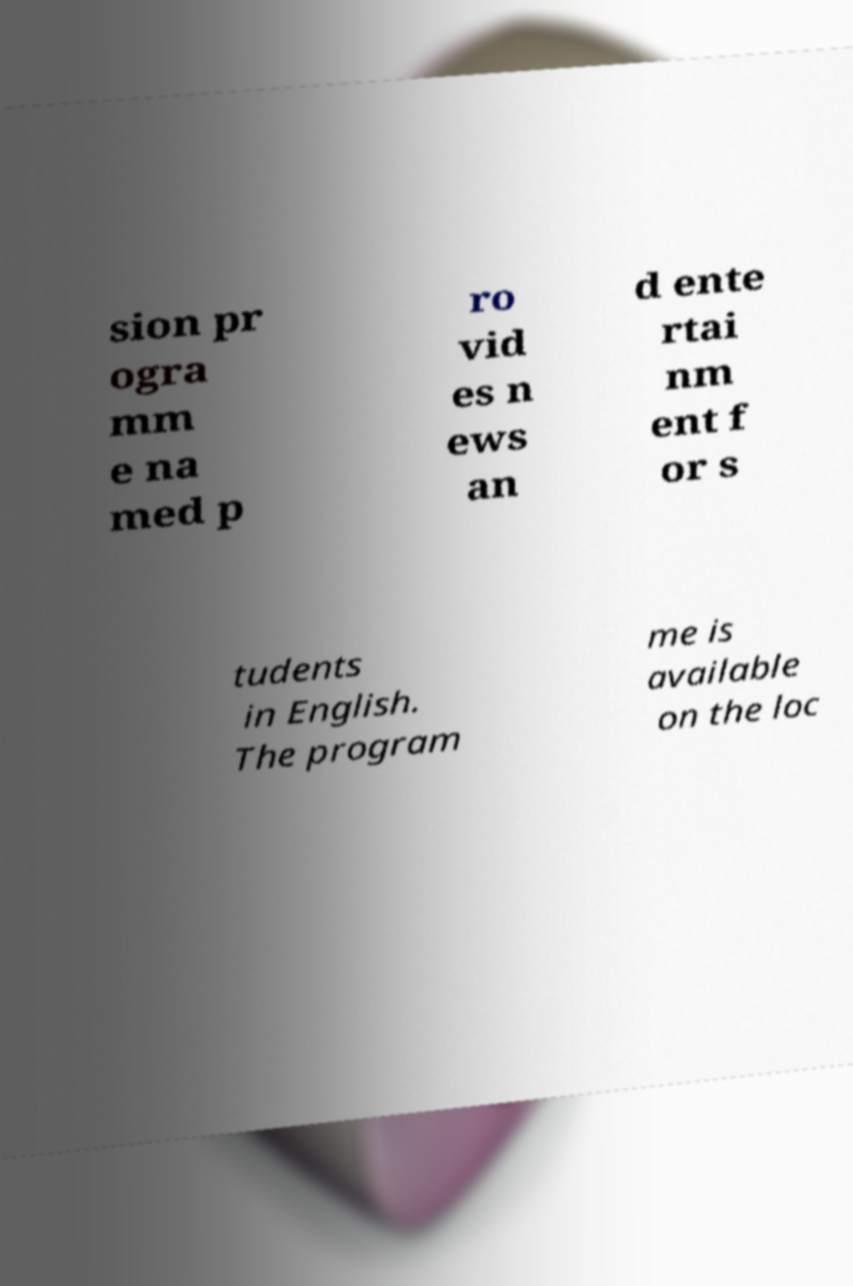Can you accurately transcribe the text from the provided image for me? sion pr ogra mm e na med p ro vid es n ews an d ente rtai nm ent f or s tudents in English. The program me is available on the loc 